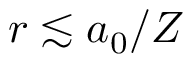<formula> <loc_0><loc_0><loc_500><loc_500>r \lesssim a _ { 0 } / Z</formula> 